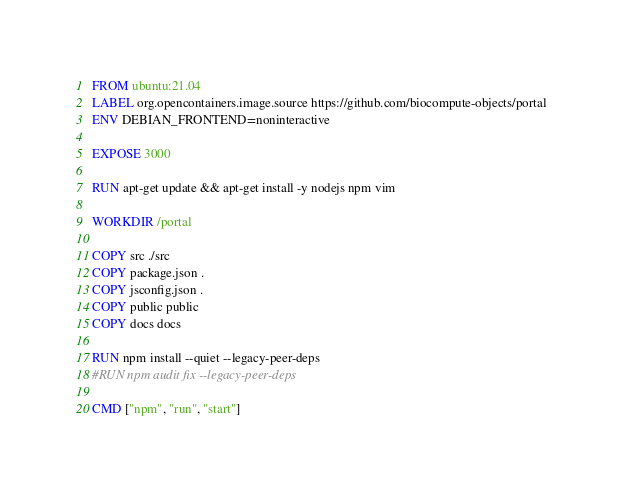Convert code to text. <code><loc_0><loc_0><loc_500><loc_500><_Dockerfile_>FROM ubuntu:21.04
LABEL org.opencontainers.image.source https://github.com/biocompute-objects/portal
ENV DEBIAN_FRONTEND=noninteractive

EXPOSE 3000

RUN apt-get update && apt-get install -y nodejs npm vim

WORKDIR /portal

COPY src ./src
COPY package.json .
COPY jsconfig.json .
COPY public public
COPY docs docs

RUN npm install --quiet --legacy-peer-deps
#RUN npm audit fix --legacy-peer-deps

CMD ["npm", "run", "start"]</code> 